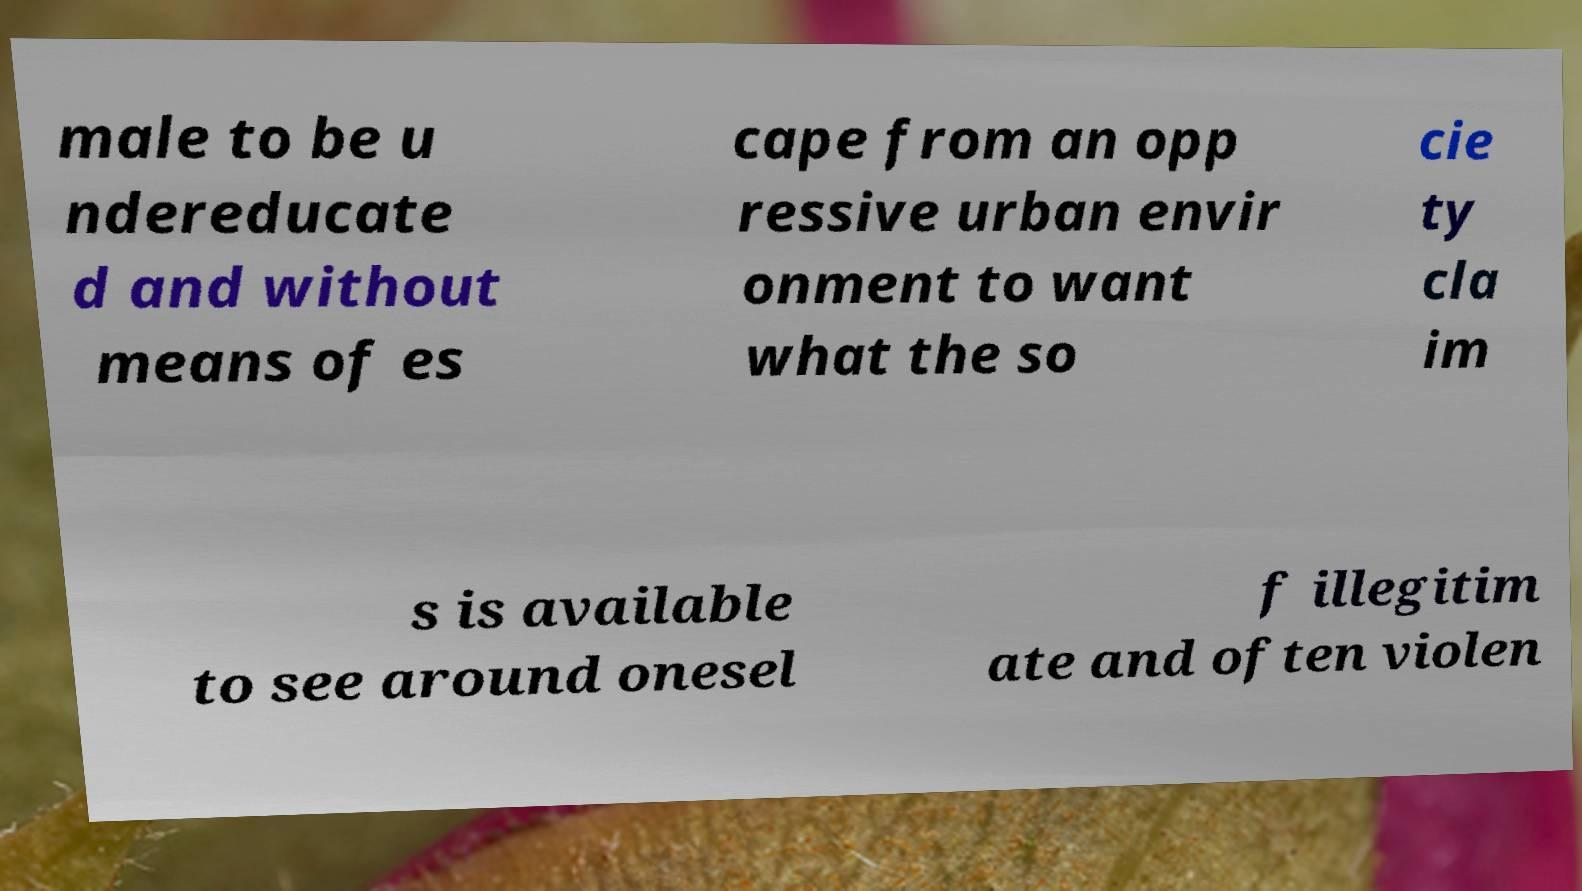For documentation purposes, I need the text within this image transcribed. Could you provide that? male to be u ndereducate d and without means of es cape from an opp ressive urban envir onment to want what the so cie ty cla im s is available to see around onesel f illegitim ate and often violen 